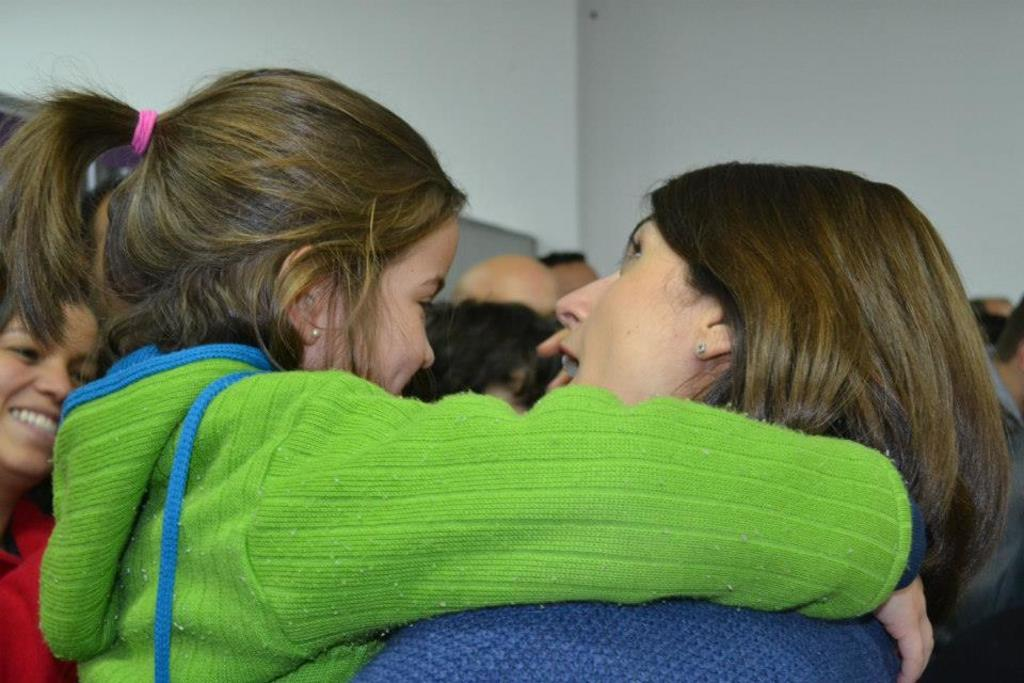Who is the main subject in the image? There is a woman in the image. What is the woman doing in the image? The woman is carrying a girl. What is the girl wearing in the image? The girl is wearing a green hoodie. Can you describe the surroundings in the image? There are other people in the room, and the walls in the room are white. What type of scarecrow can be seen in the image? There is no scarecrow present in the image. Is the girl in the image being guided by the woman? The image does not provide information about the woman guiding the girl, but it shows the woman carrying her. 